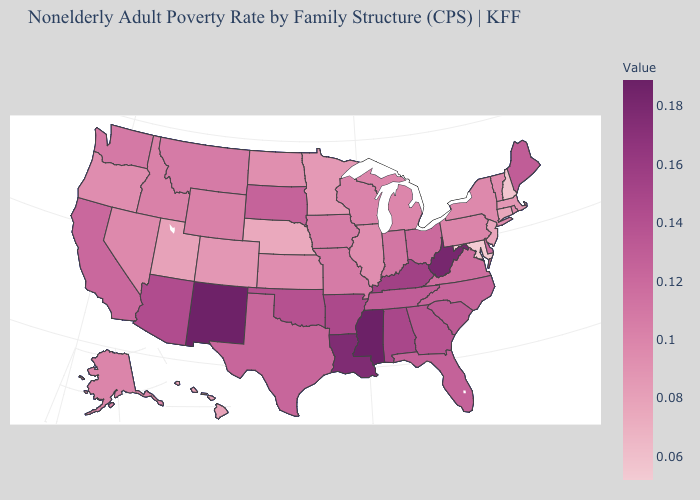Which states hav the highest value in the MidWest?
Short answer required. South Dakota. Which states have the lowest value in the West?
Answer briefly. Hawaii, Utah. Does Maryland have the lowest value in the South?
Write a very short answer. Yes. Which states have the lowest value in the South?
Give a very brief answer. Maryland. Does the map have missing data?
Keep it brief. No. Among the states that border North Carolina , does Virginia have the lowest value?
Concise answer only. Yes. 